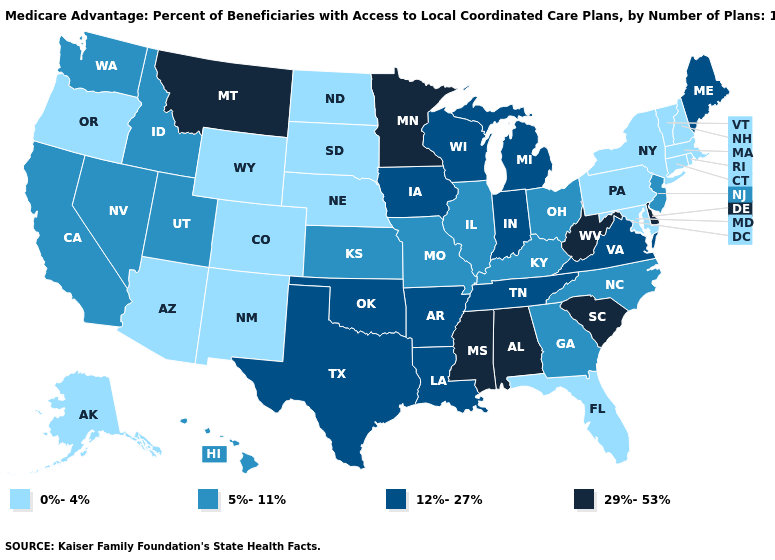Which states have the highest value in the USA?
Concise answer only. Alabama, Delaware, Minnesota, Mississippi, Montana, South Carolina, West Virginia. What is the highest value in the USA?
Be succinct. 29%-53%. Among the states that border Florida , does Alabama have the highest value?
Answer briefly. Yes. What is the value of California?
Write a very short answer. 5%-11%. Does New Jersey have the same value as Utah?
Keep it brief. Yes. Does Washington have the same value as North Dakota?
Keep it brief. No. Which states have the lowest value in the South?
Write a very short answer. Florida, Maryland. What is the value of Tennessee?
Write a very short answer. 12%-27%. Name the states that have a value in the range 0%-4%?
Write a very short answer. Alaska, Arizona, Colorado, Connecticut, Florida, Massachusetts, Maryland, North Dakota, Nebraska, New Hampshire, New Mexico, New York, Oregon, Pennsylvania, Rhode Island, South Dakota, Vermont, Wyoming. Among the states that border North Dakota , which have the highest value?
Quick response, please. Minnesota, Montana. What is the value of Mississippi?
Quick response, please. 29%-53%. Does Indiana have the highest value in the MidWest?
Write a very short answer. No. What is the lowest value in the Northeast?
Be succinct. 0%-4%. Among the states that border Georgia , which have the highest value?
Answer briefly. Alabama, South Carolina. Does the first symbol in the legend represent the smallest category?
Be succinct. Yes. 